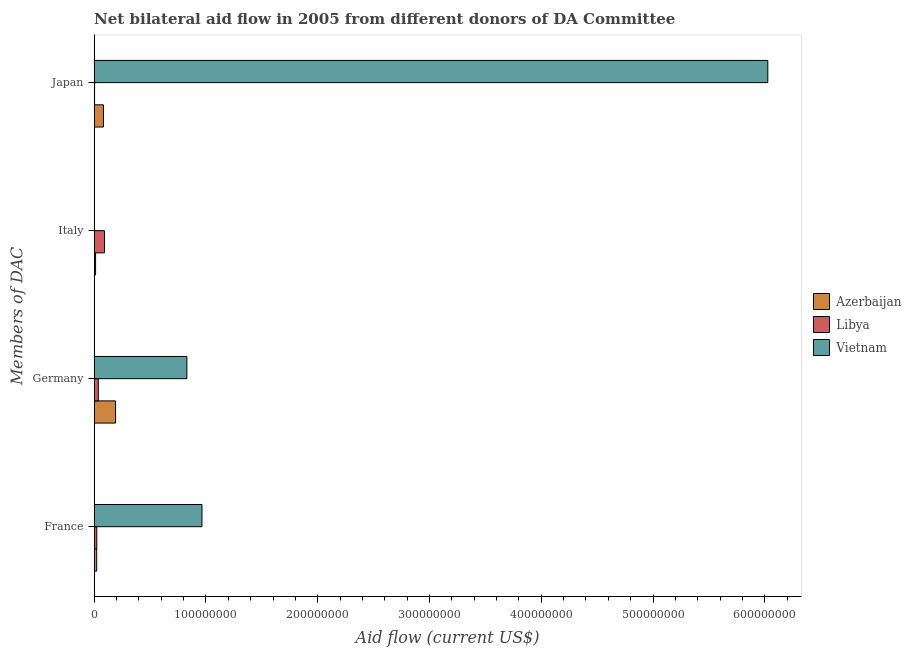How many different coloured bars are there?
Ensure brevity in your answer.  3. How many groups of bars are there?
Your response must be concise. 4. Are the number of bars per tick equal to the number of legend labels?
Provide a succinct answer. No. How many bars are there on the 2nd tick from the top?
Offer a very short reply. 2. What is the label of the 4th group of bars from the top?
Provide a short and direct response. France. What is the amount of aid given by japan in Vietnam?
Your answer should be very brief. 6.03e+08. Across all countries, what is the maximum amount of aid given by japan?
Provide a short and direct response. 6.03e+08. In which country was the amount of aid given by germany maximum?
Your response must be concise. Vietnam. What is the total amount of aid given by france in the graph?
Offer a very short reply. 1.01e+08. What is the difference between the amount of aid given by france in Azerbaijan and that in Libya?
Ensure brevity in your answer.  -1.10e+05. What is the difference between the amount of aid given by germany in Azerbaijan and the amount of aid given by france in Vietnam?
Offer a very short reply. -7.73e+07. What is the average amount of aid given by france per country?
Provide a short and direct response. 3.37e+07. What is the difference between the amount of aid given by japan and amount of aid given by germany in Libya?
Make the answer very short. -3.32e+06. What is the ratio of the amount of aid given by japan in Libya to that in Vietnam?
Provide a short and direct response. 0. What is the difference between the highest and the second highest amount of aid given by france?
Your response must be concise. 9.41e+07. What is the difference between the highest and the lowest amount of aid given by italy?
Give a very brief answer. 9.25e+06. Is the sum of the amount of aid given by italy in Libya and Azerbaijan greater than the maximum amount of aid given by japan across all countries?
Provide a short and direct response. No. Is it the case that in every country, the sum of the amount of aid given by france and amount of aid given by germany is greater than the amount of aid given by italy?
Give a very brief answer. No. How many bars are there?
Offer a terse response. 11. Are all the bars in the graph horizontal?
Keep it short and to the point. Yes. How many countries are there in the graph?
Offer a very short reply. 3. What is the difference between two consecutive major ticks on the X-axis?
Keep it short and to the point. 1.00e+08. Are the values on the major ticks of X-axis written in scientific E-notation?
Offer a terse response. No. Does the graph contain any zero values?
Give a very brief answer. Yes. Does the graph contain grids?
Provide a short and direct response. No. What is the title of the graph?
Your answer should be very brief. Net bilateral aid flow in 2005 from different donors of DA Committee. What is the label or title of the Y-axis?
Keep it short and to the point. Members of DAC. What is the Aid flow (current US$) of Azerbaijan in France?
Your answer should be compact. 2.22e+06. What is the Aid flow (current US$) of Libya in France?
Your response must be concise. 2.33e+06. What is the Aid flow (current US$) in Vietnam in France?
Your answer should be very brief. 9.64e+07. What is the Aid flow (current US$) of Azerbaijan in Germany?
Offer a very short reply. 1.91e+07. What is the Aid flow (current US$) in Libya in Germany?
Provide a short and direct response. 3.65e+06. What is the Aid flow (current US$) in Vietnam in Germany?
Provide a short and direct response. 8.29e+07. What is the Aid flow (current US$) in Azerbaijan in Italy?
Your answer should be compact. 1.24e+06. What is the Aid flow (current US$) of Libya in Italy?
Offer a very short reply. 9.25e+06. What is the Aid flow (current US$) in Vietnam in Italy?
Make the answer very short. 0. What is the Aid flow (current US$) in Azerbaijan in Japan?
Provide a short and direct response. 8.25e+06. What is the Aid flow (current US$) in Vietnam in Japan?
Your answer should be very brief. 6.03e+08. Across all Members of DAC, what is the maximum Aid flow (current US$) of Azerbaijan?
Give a very brief answer. 1.91e+07. Across all Members of DAC, what is the maximum Aid flow (current US$) of Libya?
Make the answer very short. 9.25e+06. Across all Members of DAC, what is the maximum Aid flow (current US$) in Vietnam?
Ensure brevity in your answer.  6.03e+08. Across all Members of DAC, what is the minimum Aid flow (current US$) of Azerbaijan?
Ensure brevity in your answer.  1.24e+06. Across all Members of DAC, what is the minimum Aid flow (current US$) in Libya?
Ensure brevity in your answer.  3.30e+05. Across all Members of DAC, what is the minimum Aid flow (current US$) of Vietnam?
Give a very brief answer. 0. What is the total Aid flow (current US$) of Azerbaijan in the graph?
Keep it short and to the point. 3.08e+07. What is the total Aid flow (current US$) of Libya in the graph?
Give a very brief answer. 1.56e+07. What is the total Aid flow (current US$) of Vietnam in the graph?
Ensure brevity in your answer.  7.82e+08. What is the difference between the Aid flow (current US$) in Azerbaijan in France and that in Germany?
Offer a terse response. -1.69e+07. What is the difference between the Aid flow (current US$) of Libya in France and that in Germany?
Keep it short and to the point. -1.32e+06. What is the difference between the Aid flow (current US$) of Vietnam in France and that in Germany?
Your response must be concise. 1.35e+07. What is the difference between the Aid flow (current US$) of Azerbaijan in France and that in Italy?
Make the answer very short. 9.80e+05. What is the difference between the Aid flow (current US$) in Libya in France and that in Italy?
Your answer should be very brief. -6.92e+06. What is the difference between the Aid flow (current US$) in Azerbaijan in France and that in Japan?
Provide a succinct answer. -6.03e+06. What is the difference between the Aid flow (current US$) of Libya in France and that in Japan?
Your answer should be compact. 2.00e+06. What is the difference between the Aid flow (current US$) of Vietnam in France and that in Japan?
Offer a very short reply. -5.06e+08. What is the difference between the Aid flow (current US$) in Azerbaijan in Germany and that in Italy?
Offer a terse response. 1.79e+07. What is the difference between the Aid flow (current US$) of Libya in Germany and that in Italy?
Your answer should be very brief. -5.60e+06. What is the difference between the Aid flow (current US$) of Azerbaijan in Germany and that in Japan?
Your response must be concise. 1.09e+07. What is the difference between the Aid flow (current US$) in Libya in Germany and that in Japan?
Give a very brief answer. 3.32e+06. What is the difference between the Aid flow (current US$) of Vietnam in Germany and that in Japan?
Offer a terse response. -5.20e+08. What is the difference between the Aid flow (current US$) of Azerbaijan in Italy and that in Japan?
Your answer should be compact. -7.01e+06. What is the difference between the Aid flow (current US$) of Libya in Italy and that in Japan?
Provide a short and direct response. 8.92e+06. What is the difference between the Aid flow (current US$) in Azerbaijan in France and the Aid flow (current US$) in Libya in Germany?
Offer a very short reply. -1.43e+06. What is the difference between the Aid flow (current US$) of Azerbaijan in France and the Aid flow (current US$) of Vietnam in Germany?
Ensure brevity in your answer.  -8.07e+07. What is the difference between the Aid flow (current US$) in Libya in France and the Aid flow (current US$) in Vietnam in Germany?
Your answer should be very brief. -8.06e+07. What is the difference between the Aid flow (current US$) of Azerbaijan in France and the Aid flow (current US$) of Libya in Italy?
Offer a very short reply. -7.03e+06. What is the difference between the Aid flow (current US$) of Azerbaijan in France and the Aid flow (current US$) of Libya in Japan?
Keep it short and to the point. 1.89e+06. What is the difference between the Aid flow (current US$) of Azerbaijan in France and the Aid flow (current US$) of Vietnam in Japan?
Ensure brevity in your answer.  -6.00e+08. What is the difference between the Aid flow (current US$) in Libya in France and the Aid flow (current US$) in Vietnam in Japan?
Offer a very short reply. -6.00e+08. What is the difference between the Aid flow (current US$) of Azerbaijan in Germany and the Aid flow (current US$) of Libya in Italy?
Provide a short and direct response. 9.86e+06. What is the difference between the Aid flow (current US$) of Azerbaijan in Germany and the Aid flow (current US$) of Libya in Japan?
Provide a short and direct response. 1.88e+07. What is the difference between the Aid flow (current US$) in Azerbaijan in Germany and the Aid flow (current US$) in Vietnam in Japan?
Offer a terse response. -5.84e+08. What is the difference between the Aid flow (current US$) in Libya in Germany and the Aid flow (current US$) in Vietnam in Japan?
Provide a succinct answer. -5.99e+08. What is the difference between the Aid flow (current US$) of Azerbaijan in Italy and the Aid flow (current US$) of Libya in Japan?
Provide a short and direct response. 9.10e+05. What is the difference between the Aid flow (current US$) of Azerbaijan in Italy and the Aid flow (current US$) of Vietnam in Japan?
Keep it short and to the point. -6.01e+08. What is the difference between the Aid flow (current US$) of Libya in Italy and the Aid flow (current US$) of Vietnam in Japan?
Your response must be concise. -5.93e+08. What is the average Aid flow (current US$) in Azerbaijan per Members of DAC?
Your answer should be compact. 7.70e+06. What is the average Aid flow (current US$) of Libya per Members of DAC?
Your answer should be compact. 3.89e+06. What is the average Aid flow (current US$) of Vietnam per Members of DAC?
Your answer should be very brief. 1.96e+08. What is the difference between the Aid flow (current US$) in Azerbaijan and Aid flow (current US$) in Vietnam in France?
Provide a succinct answer. -9.42e+07. What is the difference between the Aid flow (current US$) of Libya and Aid flow (current US$) of Vietnam in France?
Offer a terse response. -9.41e+07. What is the difference between the Aid flow (current US$) in Azerbaijan and Aid flow (current US$) in Libya in Germany?
Ensure brevity in your answer.  1.55e+07. What is the difference between the Aid flow (current US$) of Azerbaijan and Aid flow (current US$) of Vietnam in Germany?
Provide a short and direct response. -6.38e+07. What is the difference between the Aid flow (current US$) in Libya and Aid flow (current US$) in Vietnam in Germany?
Offer a terse response. -7.93e+07. What is the difference between the Aid flow (current US$) in Azerbaijan and Aid flow (current US$) in Libya in Italy?
Your answer should be compact. -8.01e+06. What is the difference between the Aid flow (current US$) in Azerbaijan and Aid flow (current US$) in Libya in Japan?
Offer a very short reply. 7.92e+06. What is the difference between the Aid flow (current US$) of Azerbaijan and Aid flow (current US$) of Vietnam in Japan?
Provide a succinct answer. -5.94e+08. What is the difference between the Aid flow (current US$) in Libya and Aid flow (current US$) in Vietnam in Japan?
Offer a very short reply. -6.02e+08. What is the ratio of the Aid flow (current US$) of Azerbaijan in France to that in Germany?
Your answer should be compact. 0.12. What is the ratio of the Aid flow (current US$) of Libya in France to that in Germany?
Your answer should be compact. 0.64. What is the ratio of the Aid flow (current US$) in Vietnam in France to that in Germany?
Provide a succinct answer. 1.16. What is the ratio of the Aid flow (current US$) in Azerbaijan in France to that in Italy?
Give a very brief answer. 1.79. What is the ratio of the Aid flow (current US$) in Libya in France to that in Italy?
Your answer should be compact. 0.25. What is the ratio of the Aid flow (current US$) of Azerbaijan in France to that in Japan?
Make the answer very short. 0.27. What is the ratio of the Aid flow (current US$) in Libya in France to that in Japan?
Provide a succinct answer. 7.06. What is the ratio of the Aid flow (current US$) in Vietnam in France to that in Japan?
Offer a terse response. 0.16. What is the ratio of the Aid flow (current US$) in Azerbaijan in Germany to that in Italy?
Offer a very short reply. 15.41. What is the ratio of the Aid flow (current US$) in Libya in Germany to that in Italy?
Offer a very short reply. 0.39. What is the ratio of the Aid flow (current US$) of Azerbaijan in Germany to that in Japan?
Give a very brief answer. 2.32. What is the ratio of the Aid flow (current US$) of Libya in Germany to that in Japan?
Offer a terse response. 11.06. What is the ratio of the Aid flow (current US$) in Vietnam in Germany to that in Japan?
Keep it short and to the point. 0.14. What is the ratio of the Aid flow (current US$) in Azerbaijan in Italy to that in Japan?
Offer a terse response. 0.15. What is the ratio of the Aid flow (current US$) in Libya in Italy to that in Japan?
Offer a very short reply. 28.03. What is the difference between the highest and the second highest Aid flow (current US$) of Azerbaijan?
Make the answer very short. 1.09e+07. What is the difference between the highest and the second highest Aid flow (current US$) in Libya?
Make the answer very short. 5.60e+06. What is the difference between the highest and the second highest Aid flow (current US$) of Vietnam?
Keep it short and to the point. 5.06e+08. What is the difference between the highest and the lowest Aid flow (current US$) in Azerbaijan?
Provide a succinct answer. 1.79e+07. What is the difference between the highest and the lowest Aid flow (current US$) of Libya?
Ensure brevity in your answer.  8.92e+06. What is the difference between the highest and the lowest Aid flow (current US$) in Vietnam?
Your response must be concise. 6.03e+08. 